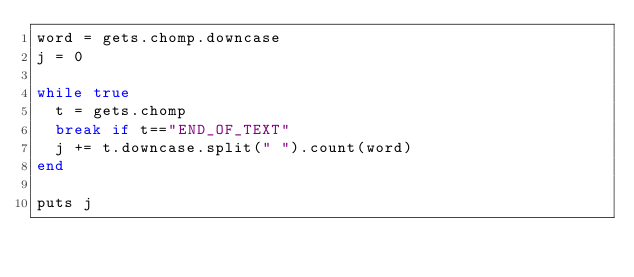Convert code to text. <code><loc_0><loc_0><loc_500><loc_500><_Ruby_>word = gets.chomp.downcase
j = 0

while true
  t = gets.chomp
  break if t=="END_OF_TEXT"
  j += t.downcase.split(" ").count(word)
end

puts j

  </code> 